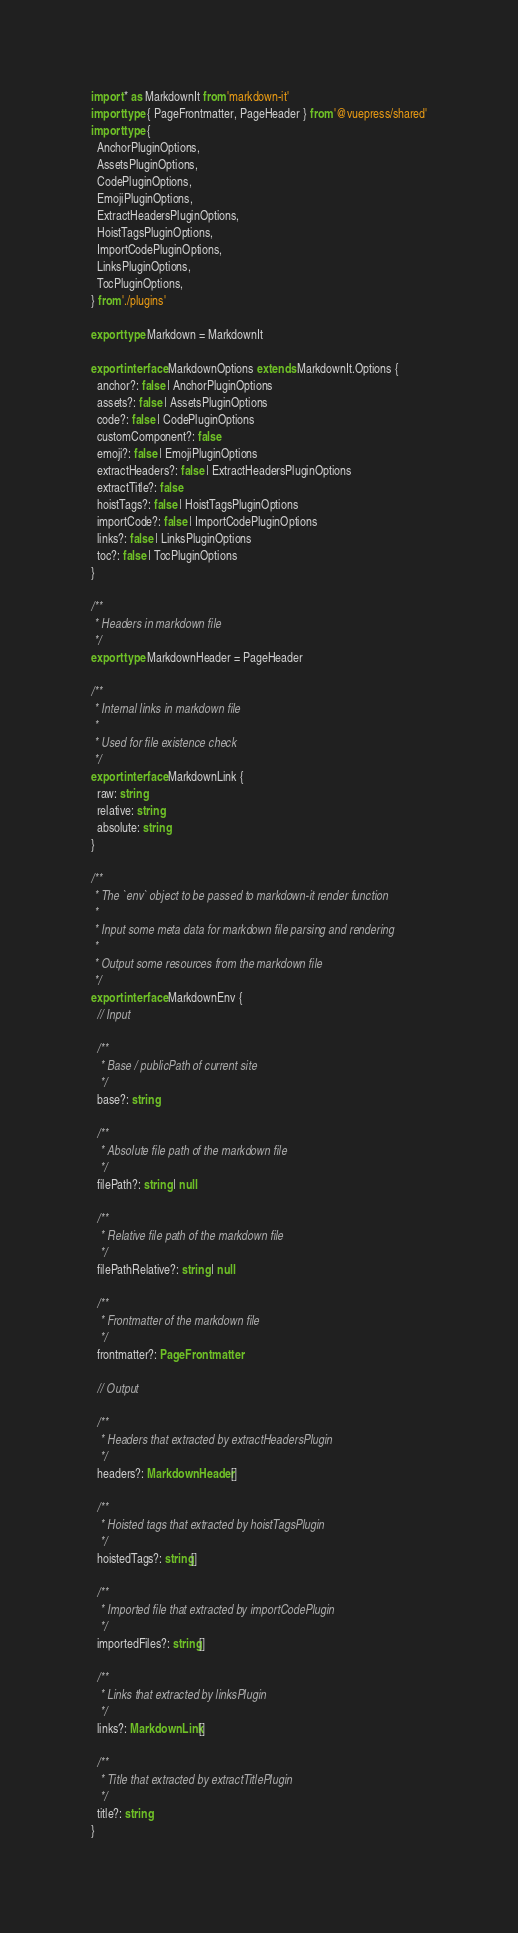<code> <loc_0><loc_0><loc_500><loc_500><_TypeScript_>import * as MarkdownIt from 'markdown-it'
import type { PageFrontmatter, PageHeader } from '@vuepress/shared'
import type {
  AnchorPluginOptions,
  AssetsPluginOptions,
  CodePluginOptions,
  EmojiPluginOptions,
  ExtractHeadersPluginOptions,
  HoistTagsPluginOptions,
  ImportCodePluginOptions,
  LinksPluginOptions,
  TocPluginOptions,
} from './plugins'

export type Markdown = MarkdownIt

export interface MarkdownOptions extends MarkdownIt.Options {
  anchor?: false | AnchorPluginOptions
  assets?: false | AssetsPluginOptions
  code?: false | CodePluginOptions
  customComponent?: false
  emoji?: false | EmojiPluginOptions
  extractHeaders?: false | ExtractHeadersPluginOptions
  extractTitle?: false
  hoistTags?: false | HoistTagsPluginOptions
  importCode?: false | ImportCodePluginOptions
  links?: false | LinksPluginOptions
  toc?: false | TocPluginOptions
}

/**
 * Headers in markdown file
 */
export type MarkdownHeader = PageHeader

/**
 * Internal links in markdown file
 *
 * Used for file existence check
 */
export interface MarkdownLink {
  raw: string
  relative: string
  absolute: string
}

/**
 * The `env` object to be passed to markdown-it render function
 *
 * Input some meta data for markdown file parsing and rendering
 *
 * Output some resources from the markdown file
 */
export interface MarkdownEnv {
  // Input

  /**
   * Base / publicPath of current site
   */
  base?: string

  /**
   * Absolute file path of the markdown file
   */
  filePath?: string | null

  /**
   * Relative file path of the markdown file
   */
  filePathRelative?: string | null

  /**
   * Frontmatter of the markdown file
   */
  frontmatter?: PageFrontmatter

  // Output

  /**
   * Headers that extracted by extractHeadersPlugin
   */
  headers?: MarkdownHeader[]

  /**
   * Hoisted tags that extracted by hoistTagsPlugin
   */
  hoistedTags?: string[]

  /**
   * Imported file that extracted by importCodePlugin
   */
  importedFiles?: string[]

  /**
   * Links that extracted by linksPlugin
   */
  links?: MarkdownLink[]

  /**
   * Title that extracted by extractTitlePlugin
   */
  title?: string
}
</code> 